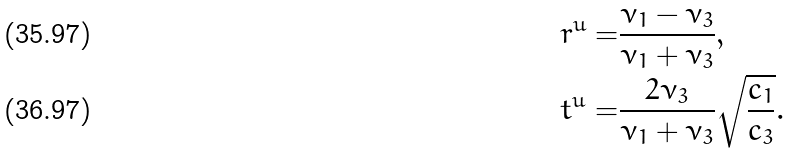Convert formula to latex. <formula><loc_0><loc_0><loc_500><loc_500>r ^ { u } = & \frac { \nu _ { 1 } - \nu _ { 3 } } { \nu _ { 1 } + \nu _ { 3 } } , \\ t ^ { u } = & \frac { 2 \nu _ { 3 } } { \nu _ { 1 } + \nu _ { 3 } } \sqrt { \frac { c _ { 1 } } { c _ { 3 } } } .</formula> 